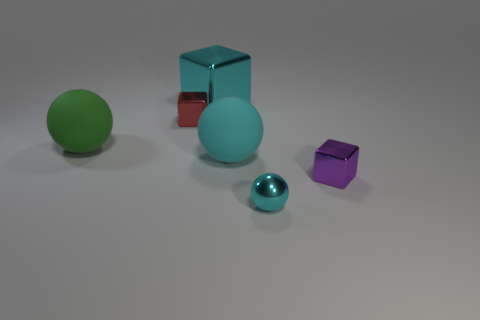Does the metal ball have the same color as the large shiny block?
Your answer should be very brief. Yes. What number of other large things are the same color as the large metal object?
Give a very brief answer. 1. There is a rubber thing in front of the green matte object; is its color the same as the tiny metal ball?
Offer a very short reply. Yes. What is the size of the matte thing that is the same color as the tiny sphere?
Provide a succinct answer. Large. What is the size of the shiny object that is both in front of the cyan cube and behind the purple shiny cube?
Keep it short and to the point. Small. The big thing on the right side of the cyan metallic thing that is to the left of the large rubber thing on the right side of the big cube is made of what material?
Give a very brief answer. Rubber. There is another ball that is the same color as the metal sphere; what is it made of?
Offer a terse response. Rubber. Does the shiny cube behind the small red block have the same color as the tiny metallic thing that is in front of the small purple shiny thing?
Provide a short and direct response. Yes. The cyan rubber object that is on the right side of the tiny object behind the small cube that is in front of the tiny red metal block is what shape?
Offer a terse response. Sphere. There is a tiny thing that is both on the left side of the purple thing and in front of the cyan matte object; what is its shape?
Make the answer very short. Sphere. 